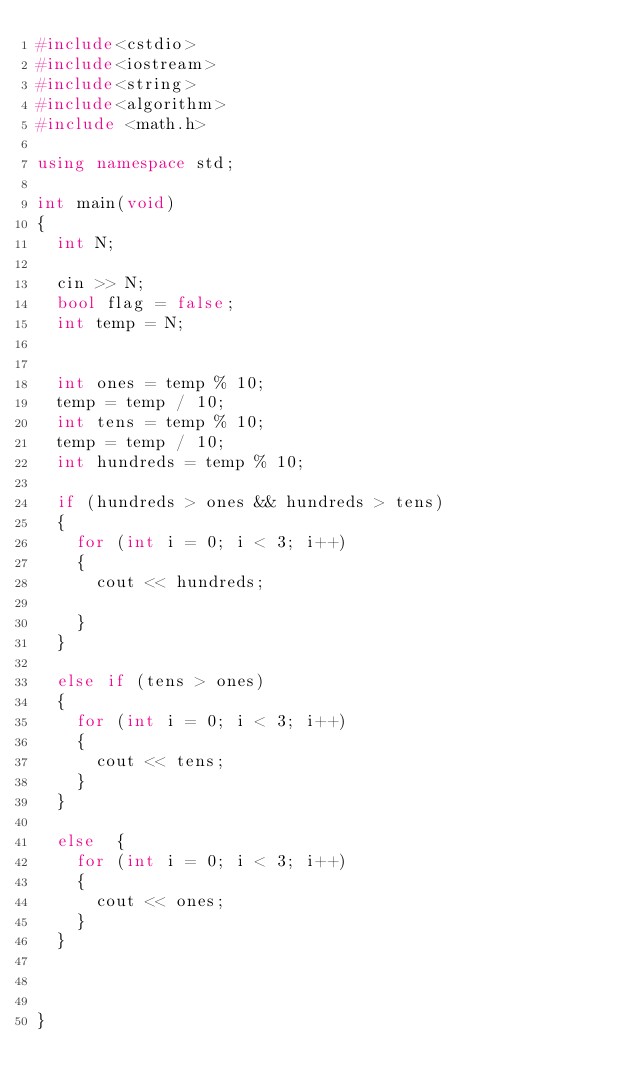Convert code to text. <code><loc_0><loc_0><loc_500><loc_500><_C++_>#include<cstdio>
#include<iostream>
#include<string>
#include<algorithm>
#include <math.h> 

using namespace std;

int main(void)
{
	int N;

	cin >> N;
	bool flag = false;
	int temp = N;


	int ones = temp % 10;
	temp = temp / 10;
	int tens = temp % 10;
	temp = temp / 10;
	int hundreds = temp % 10;

	if (hundreds > ones && hundreds > tens)
	{
		for (int i = 0; i < 3; i++)
		{
			cout << hundreds;

		}
	}

	else if (tens > ones)
	{
		for (int i = 0; i < 3; i++)
		{
			cout << tens;
		}
	}

	else 	{
		for (int i = 0; i < 3; i++)
		{
			cout << ones;
		}
	}



}
</code> 